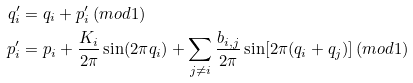<formula> <loc_0><loc_0><loc_500><loc_500>q _ { i } ^ { \prime } & = q _ { i } + p _ { i } ^ { \prime } \, ( m o d 1 ) \\ p _ { i } ^ { \prime } & = p _ { i } + \frac { K _ { i } } { 2 \pi } \sin ( 2 \pi q _ { i } ) + \sum _ { j \ne i } \frac { b _ { i , j } } { 2 \pi } \sin [ 2 \pi ( q _ { i } + q _ { j } ) ] \, ( m o d 1 )</formula> 